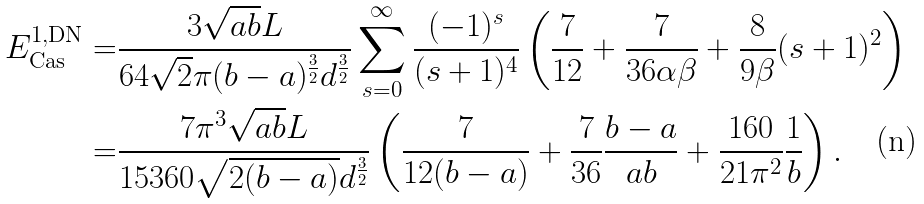Convert formula to latex. <formula><loc_0><loc_0><loc_500><loc_500>E _ { \text {Cas} } ^ { 1 , \text {DN} } = & \frac { 3 \sqrt { a b } L } { 6 4 \sqrt { 2 } \pi ( b - a ) ^ { \frac { 3 } { 2 } } d ^ { \frac { 3 } { 2 } } } \sum _ { s = 0 } ^ { \infty } \frac { ( - 1 ) ^ { s } } { ( s + 1 ) ^ { 4 } } \left ( \frac { 7 } { 1 2 } + \frac { 7 } { 3 6 \alpha \beta } + \frac { 8 } { 9 \beta } ( s + 1 ) ^ { 2 } \right ) \\ = & \frac { 7 \pi ^ { 3 } \sqrt { a b } L } { 1 5 3 6 0 \sqrt { 2 ( b - a ) } d ^ { \frac { 3 } { 2 } } } \left ( \frac { 7 } { 1 2 ( b - a ) } + \frac { 7 } { 3 6 } \frac { b - a } { a b } + \frac { 1 6 0 } { 2 1 \pi ^ { 2 } } \frac { 1 } { b } \right ) .</formula> 